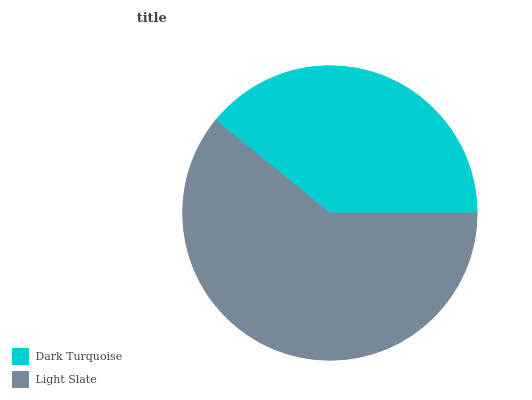Is Dark Turquoise the minimum?
Answer yes or no. Yes. Is Light Slate the maximum?
Answer yes or no. Yes. Is Light Slate the minimum?
Answer yes or no. No. Is Light Slate greater than Dark Turquoise?
Answer yes or no. Yes. Is Dark Turquoise less than Light Slate?
Answer yes or no. Yes. Is Dark Turquoise greater than Light Slate?
Answer yes or no. No. Is Light Slate less than Dark Turquoise?
Answer yes or no. No. Is Light Slate the high median?
Answer yes or no. Yes. Is Dark Turquoise the low median?
Answer yes or no. Yes. Is Dark Turquoise the high median?
Answer yes or no. No. Is Light Slate the low median?
Answer yes or no. No. 